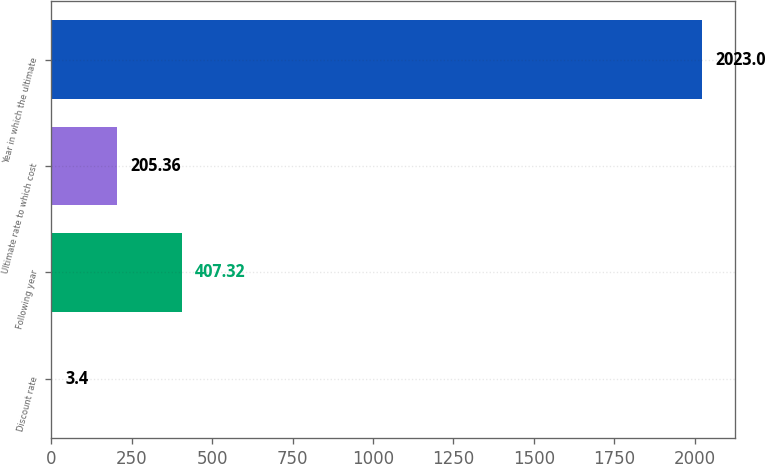<chart> <loc_0><loc_0><loc_500><loc_500><bar_chart><fcel>Discount rate<fcel>Following year<fcel>Ultimate rate to which cost<fcel>Year in which the ultimate<nl><fcel>3.4<fcel>407.32<fcel>205.36<fcel>2023<nl></chart> 